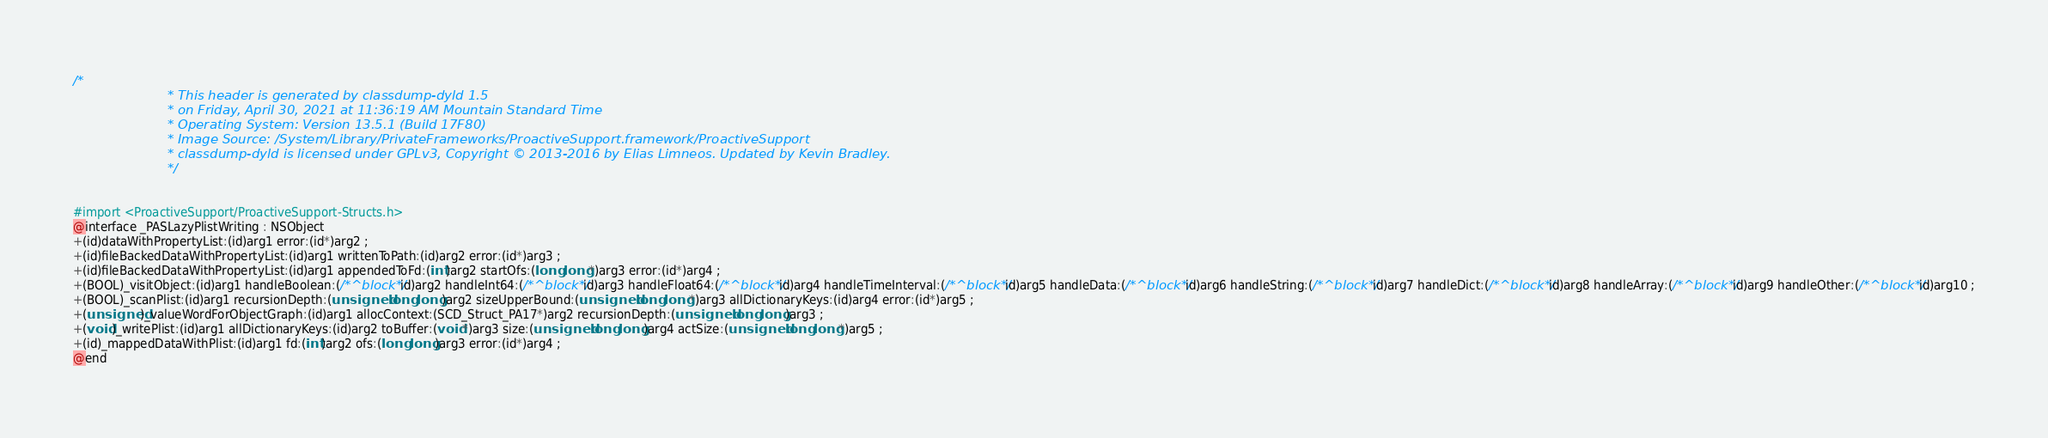<code> <loc_0><loc_0><loc_500><loc_500><_C_>/*
                       * This header is generated by classdump-dyld 1.5
                       * on Friday, April 30, 2021 at 11:36:19 AM Mountain Standard Time
                       * Operating System: Version 13.5.1 (Build 17F80)
                       * Image Source: /System/Library/PrivateFrameworks/ProactiveSupport.framework/ProactiveSupport
                       * classdump-dyld is licensed under GPLv3, Copyright © 2013-2016 by Elias Limneos. Updated by Kevin Bradley.
                       */


#import <ProactiveSupport/ProactiveSupport-Structs.h>
@interface _PASLazyPlistWriting : NSObject
+(id)dataWithPropertyList:(id)arg1 error:(id*)arg2 ;
+(id)fileBackedDataWithPropertyList:(id)arg1 writtenToPath:(id)arg2 error:(id*)arg3 ;
+(id)fileBackedDataWithPropertyList:(id)arg1 appendedToFd:(int)arg2 startOfs:(long long*)arg3 error:(id*)arg4 ;
+(BOOL)_visitObject:(id)arg1 handleBoolean:(/*^block*/id)arg2 handleInt64:(/*^block*/id)arg3 handleFloat64:(/*^block*/id)arg4 handleTimeInterval:(/*^block*/id)arg5 handleData:(/*^block*/id)arg6 handleString:(/*^block*/id)arg7 handleDict:(/*^block*/id)arg8 handleArray:(/*^block*/id)arg9 handleOther:(/*^block*/id)arg10 ;
+(BOOL)_scanPlist:(id)arg1 recursionDepth:(unsigned long long)arg2 sizeUpperBound:(unsigned long long*)arg3 allDictionaryKeys:(id)arg4 error:(id*)arg5 ;
+(unsigned)_valueWordForObjectGraph:(id)arg1 allocContext:(SCD_Struct_PA17*)arg2 recursionDepth:(unsigned long long)arg3 ;
+(void)_writePlist:(id)arg1 allDictionaryKeys:(id)arg2 toBuffer:(void*)arg3 size:(unsigned long long)arg4 actSize:(unsigned long long*)arg5 ;
+(id)_mappedDataWithPlist:(id)arg1 fd:(int)arg2 ofs:(long long)arg3 error:(id*)arg4 ;
@end

</code> 